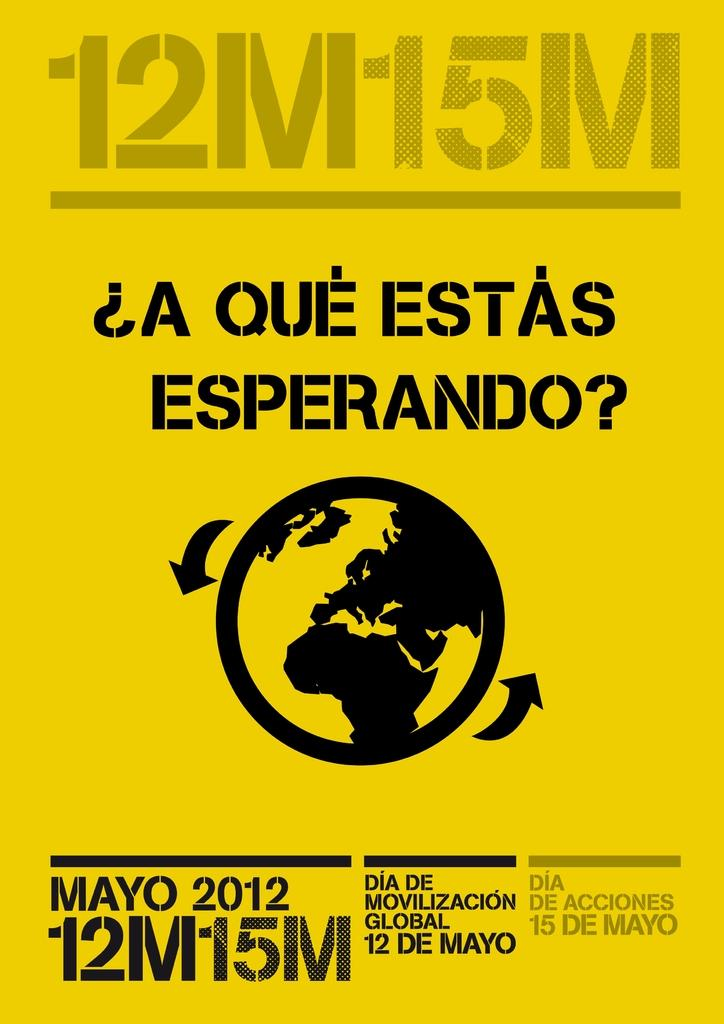What color is the poster in the image? The poster is yellow. What can be seen on the poster besides the color? There is an icon on the poster. Where is the text located in relation to the icon? There is text above and below the icon. How many roots can be seen growing from the cactus on the poster? There is no cactus present on the poster, and therefore no roots can be seen. What type of arithmetic problem is being solved on the poster? There is no arithmetic problem present on the poster. 